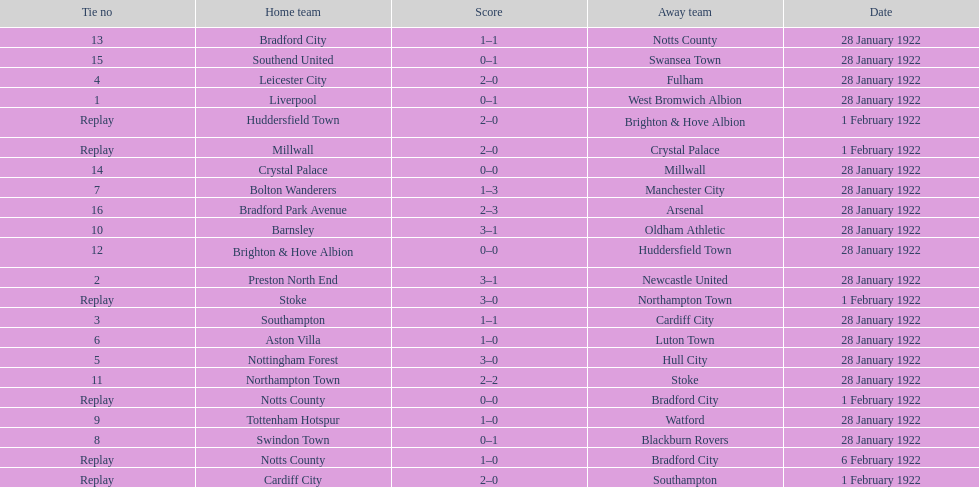Which game had a higher total number of goals scored, 1 or 16? 16. 